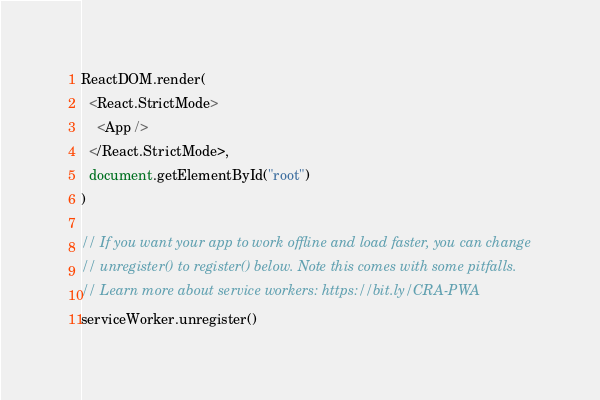<code> <loc_0><loc_0><loc_500><loc_500><_JavaScript_>ReactDOM.render(
  <React.StrictMode>
    <App />
  </React.StrictMode>,
  document.getElementById("root")
)

// If you want your app to work offline and load faster, you can change
// unregister() to register() below. Note this comes with some pitfalls.
// Learn more about service workers: https://bit.ly/CRA-PWA
serviceWorker.unregister()
</code> 